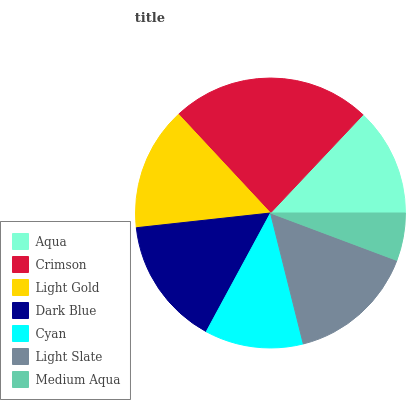Is Medium Aqua the minimum?
Answer yes or no. Yes. Is Crimson the maximum?
Answer yes or no. Yes. Is Light Gold the minimum?
Answer yes or no. No. Is Light Gold the maximum?
Answer yes or no. No. Is Crimson greater than Light Gold?
Answer yes or no. Yes. Is Light Gold less than Crimson?
Answer yes or no. Yes. Is Light Gold greater than Crimson?
Answer yes or no. No. Is Crimson less than Light Gold?
Answer yes or no. No. Is Light Gold the high median?
Answer yes or no. Yes. Is Light Gold the low median?
Answer yes or no. Yes. Is Cyan the high median?
Answer yes or no. No. Is Dark Blue the low median?
Answer yes or no. No. 